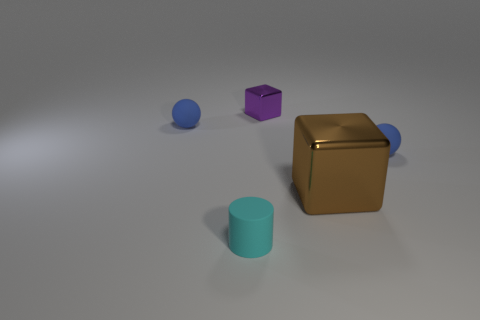There is a large thing that is made of the same material as the tiny purple object; what color is it?
Offer a terse response. Brown. What color is the big object that is the same shape as the tiny purple thing?
Give a very brief answer. Brown. There is another purple thing that is the same shape as the large object; what size is it?
Offer a terse response. Small. Is the number of small blue balls right of the brown metallic cube less than the number of tiny rubber balls in front of the matte cylinder?
Make the answer very short. No. There is a matte thing in front of the brown metal cube; is its size the same as the big brown block?
Ensure brevity in your answer.  No. There is a cylinder; what number of small purple objects are behind it?
Provide a succinct answer. 1. Are there any other matte things of the same size as the cyan object?
Offer a terse response. Yes. Does the small rubber cylinder have the same color as the big thing?
Ensure brevity in your answer.  No. There is a object on the left side of the rubber thing in front of the big brown metallic object; what is its color?
Ensure brevity in your answer.  Blue. How many objects are both in front of the small purple cube and on the right side of the cyan thing?
Your response must be concise. 2. 